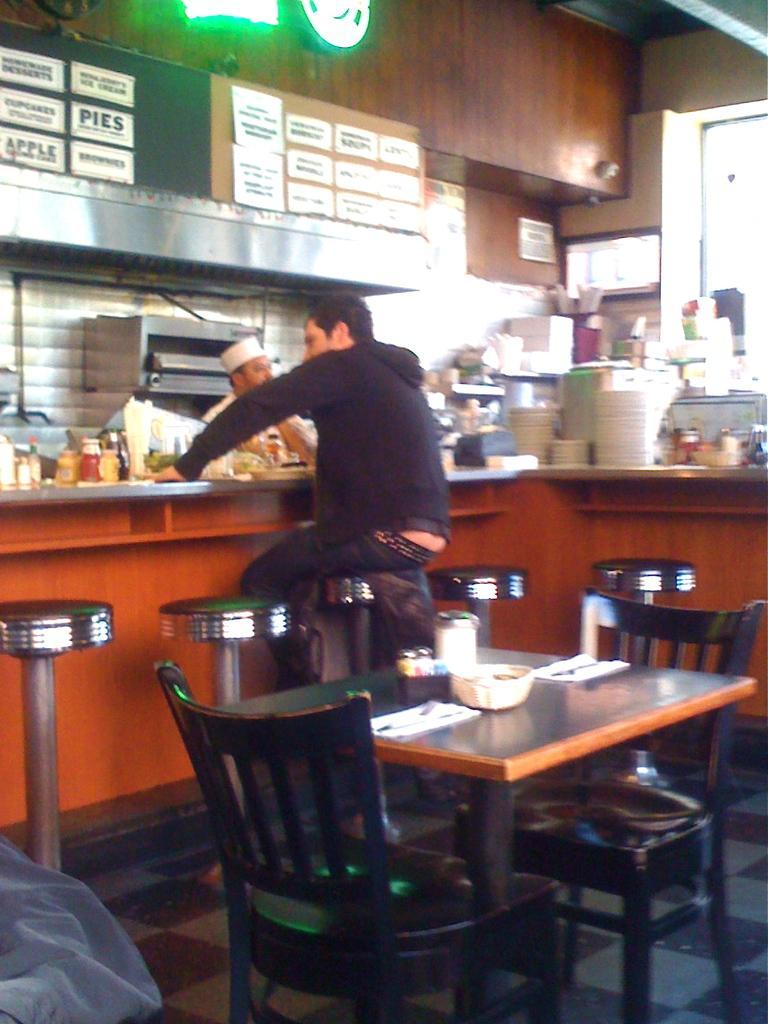Please provide a concise description of this image. In this Image I see 2 chairs, a table on which there are few things on it and I see 5 stools on which there is a man sitting on this and I see a table on which there are many things. In the background I see another person, an equipment and the wall. 